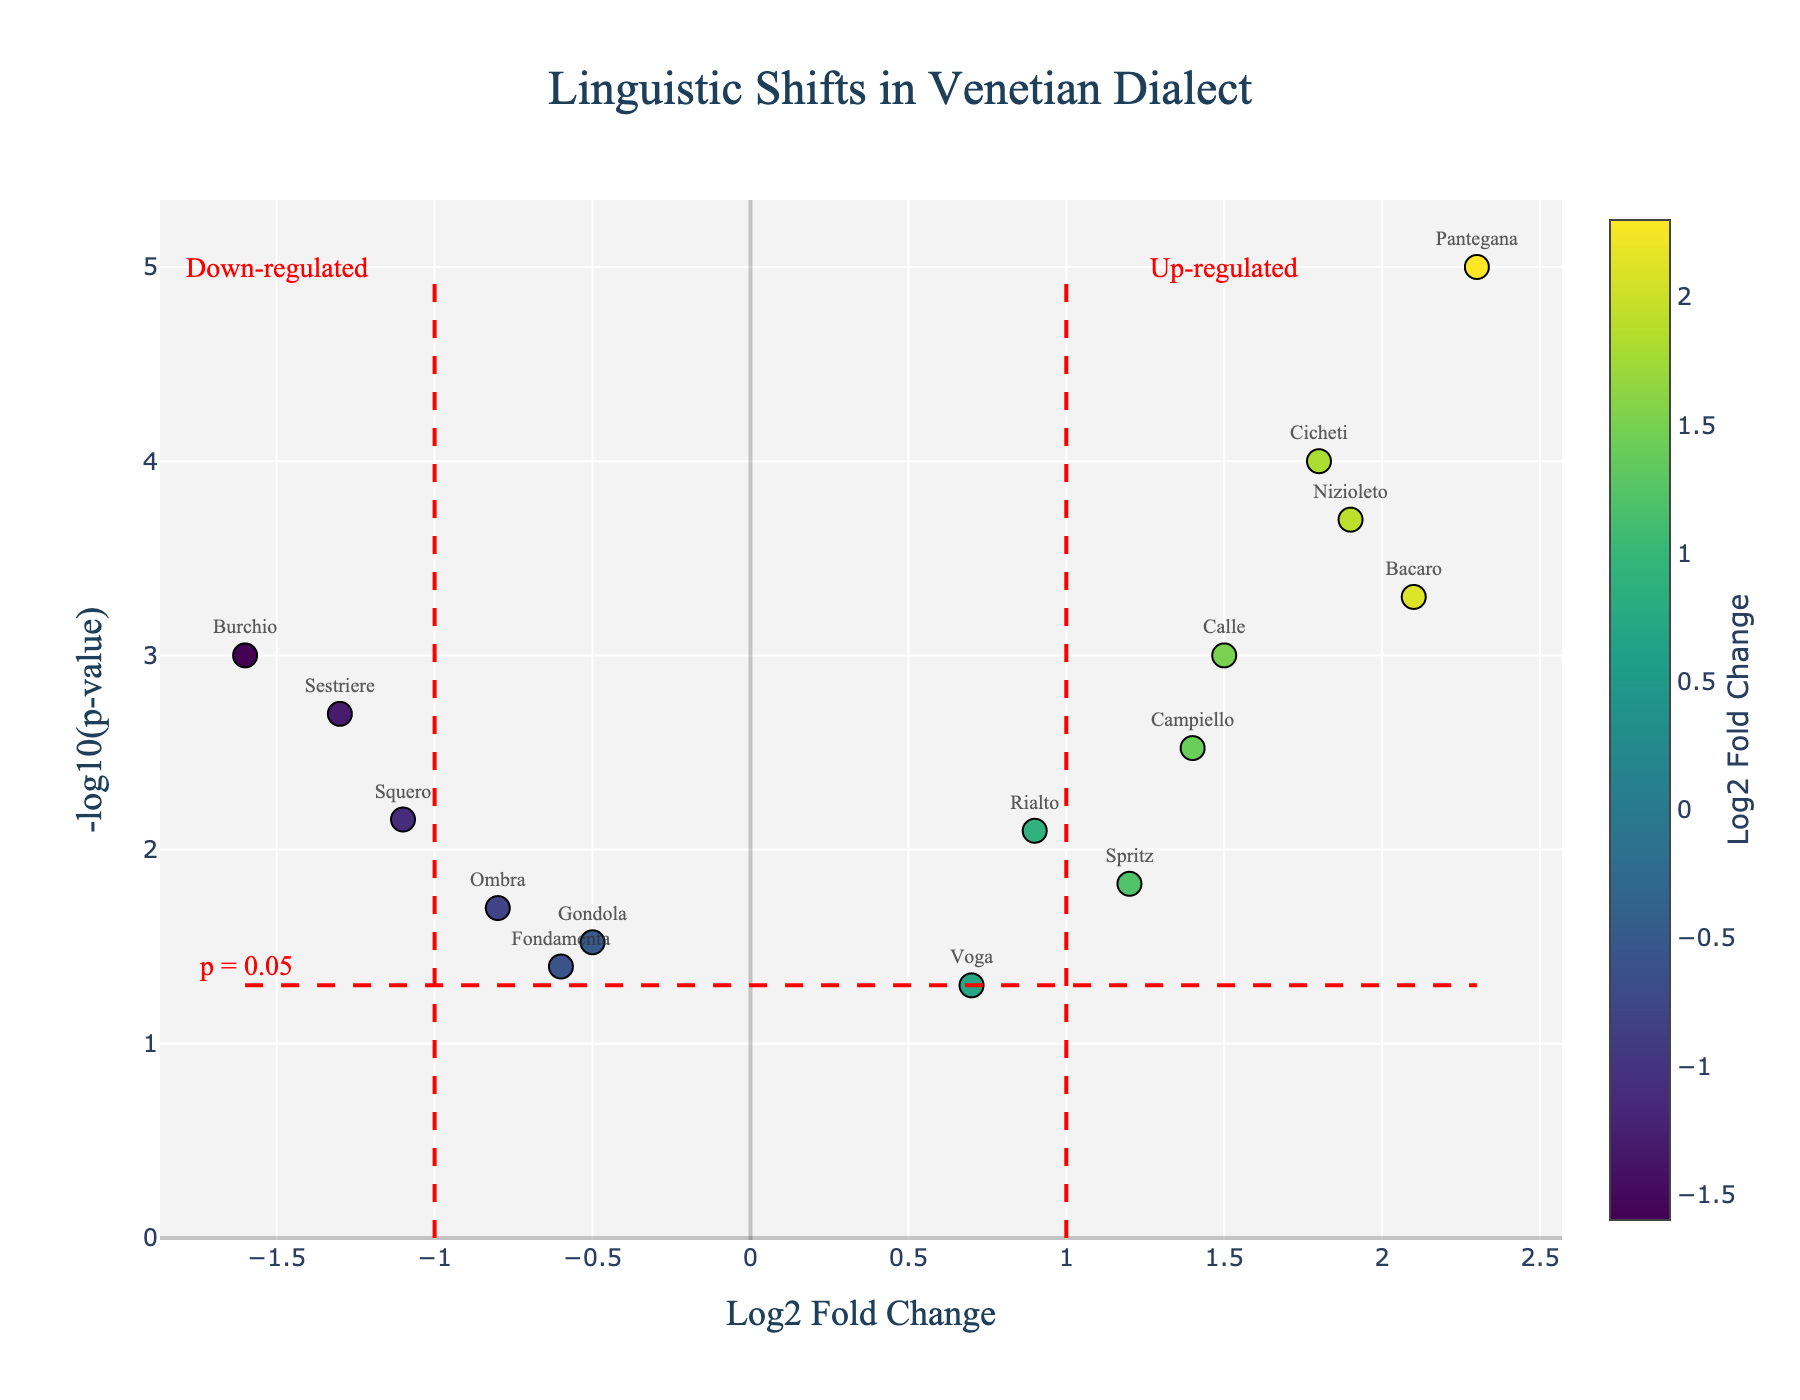What is the title of the plot? The title is located at the top of the plot and is usually in larger, bold font. Here, it reads "Linguistic Shifts in Venetian Dialect."
Answer: Linguistic Shifts in Venetian Dialect Which word has the highest -log10(p-value)? The -log10(p-value) is on the y-axis. The word "Pantegana" is at the highest position on the y-axis, indicating it has the highest -log10(p-value).
Answer: Pantegana How many words have positive Log2 Fold Change values? Positive Log2 Fold Change values are located to the right of the y-axis. The words "Calle," "Bacaro," "Spritz," "Rialto," "Cicheti," "Voga," "Pantegana," "Campiello," and "Nizioleto" are on this side. Counting these gives 9 words.
Answer: 9 Which word has the most negative Log2 Fold Change value? The Log2 Fold Change is on the x-axis. The word "Burchio" is furthest to the left, indicating it has the most negative value.
Answer: Burchio How many words have a p-value less than 0.05? The horizontal red line in the plot represents the p-value threshold of 0.05. Words above this line are "Calle," "Ombra," "Bacaro," "Spritz," "Rialto," "Sestriere," "Cicheti," "Squero," "Burchio," "Campiello," and "Nizioleto." Counting these gives 11 words.
Answer: 11 Which word is both highly used (high Log2 Fold Change) and statistically significant (low p-value)? "Pantegana" is located in the upper-right quadrant of the plot, indicating it has a high Log2 Fold Change and low p-value.
Answer: Pantegana Between "Squero" and "Fondamenta," which has a lower p-value? The lower the p-value, the higher the -log10(p-value) on the plot. "Squero" is higher on the y-axis compared to "Fondamenta," meaning it has a lower p-value.
Answer: Squero How does the Log2 Fold Change of "Gondola" compare to "Voga"? Look at the position on the x-axis. "Gondola" is slightly to the left (negative Log2 Fold Change) of "Voga" (positive Log2 Fold Change).
Answer: Gondola is lower Which word is closest to the p-value threshold line? The words near the horizontal line (-log10(0.05)) are "Voga" and "Fondamenta." "Voga" is slightly closer.
Answer: Voga Which word has the highest overall Log2 Fold Change increase? The word with the highest rightmost position on the x-axis is "Pantegana," indicating the highest Log2 Fold Change increase.
Answer: Pantegana 